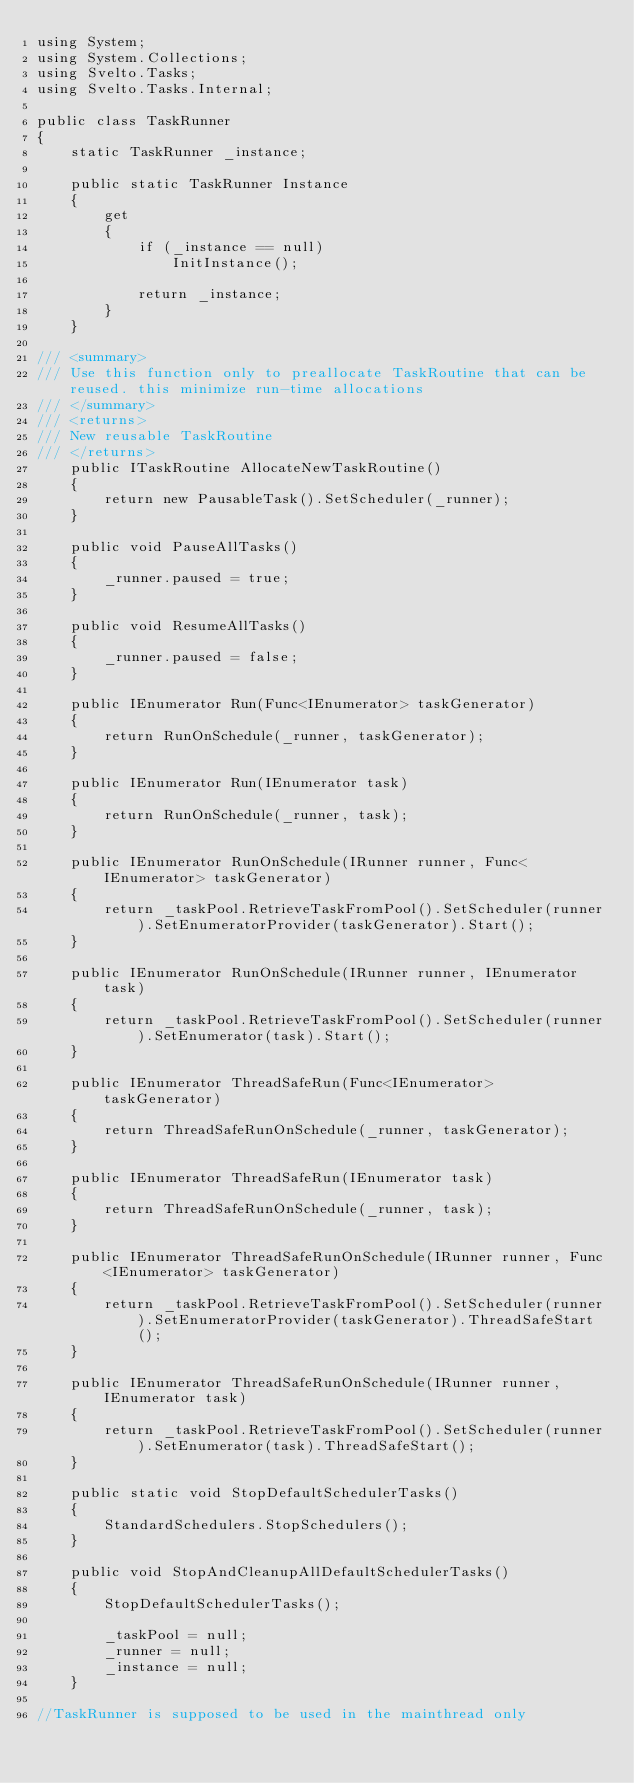<code> <loc_0><loc_0><loc_500><loc_500><_C#_>using System;
using System.Collections;
using Svelto.Tasks;
using Svelto.Tasks.Internal;

public class TaskRunner
{
    static TaskRunner _instance;

    public static TaskRunner Instance
    {
        get
        {
            if (_instance == null)
                InitInstance();

            return _instance;
        }
    }

/// <summary>
/// Use this function only to preallocate TaskRoutine that can be reused. this minimize run-time allocations
/// </summary>
/// <returns>
/// New reusable TaskRoutine
/// </returns>
    public ITaskRoutine AllocateNewTaskRoutine()
    {
        return new PausableTask().SetScheduler(_runner);
    }

    public void PauseAllTasks()
    {
        _runner.paused = true;
    }

    public void ResumeAllTasks()
    {
        _runner.paused = false;
    }

    public IEnumerator Run(Func<IEnumerator> taskGenerator)
    {
        return RunOnSchedule(_runner, taskGenerator);
    }

    public IEnumerator Run(IEnumerator task)
    {
        return RunOnSchedule(_runner, task);
    }

    public IEnumerator RunOnSchedule(IRunner runner, Func<IEnumerator> taskGenerator)
    {
        return _taskPool.RetrieveTaskFromPool().SetScheduler(runner).SetEnumeratorProvider(taskGenerator).Start();
    }

    public IEnumerator RunOnSchedule(IRunner runner, IEnumerator task)
    {
        return _taskPool.RetrieveTaskFromPool().SetScheduler(runner).SetEnumerator(task).Start();
    }

    public IEnumerator ThreadSafeRun(Func<IEnumerator> taskGenerator)
    {
        return ThreadSafeRunOnSchedule(_runner, taskGenerator);
    }

    public IEnumerator ThreadSafeRun(IEnumerator task)
    {
        return ThreadSafeRunOnSchedule(_runner, task);
    }

    public IEnumerator ThreadSafeRunOnSchedule(IRunner runner, Func<IEnumerator> taskGenerator)
    {
        return _taskPool.RetrieveTaskFromPool().SetScheduler(runner).SetEnumeratorProvider(taskGenerator).ThreadSafeStart();
    }

    public IEnumerator ThreadSafeRunOnSchedule(IRunner runner, IEnumerator task)
    {
        return _taskPool.RetrieveTaskFromPool().SetScheduler(runner).SetEnumerator(task).ThreadSafeStart();
    }

    public static void StopDefaultSchedulerTasks()
    {
        StandardSchedulers.StopSchedulers();
    }

    public void StopAndCleanupAllDefaultSchedulerTasks()
    {
        StopDefaultSchedulerTasks();

        _taskPool = null;
        _runner = null;
        _instance = null;
    }

//TaskRunner is supposed to be used in the mainthread only</code> 